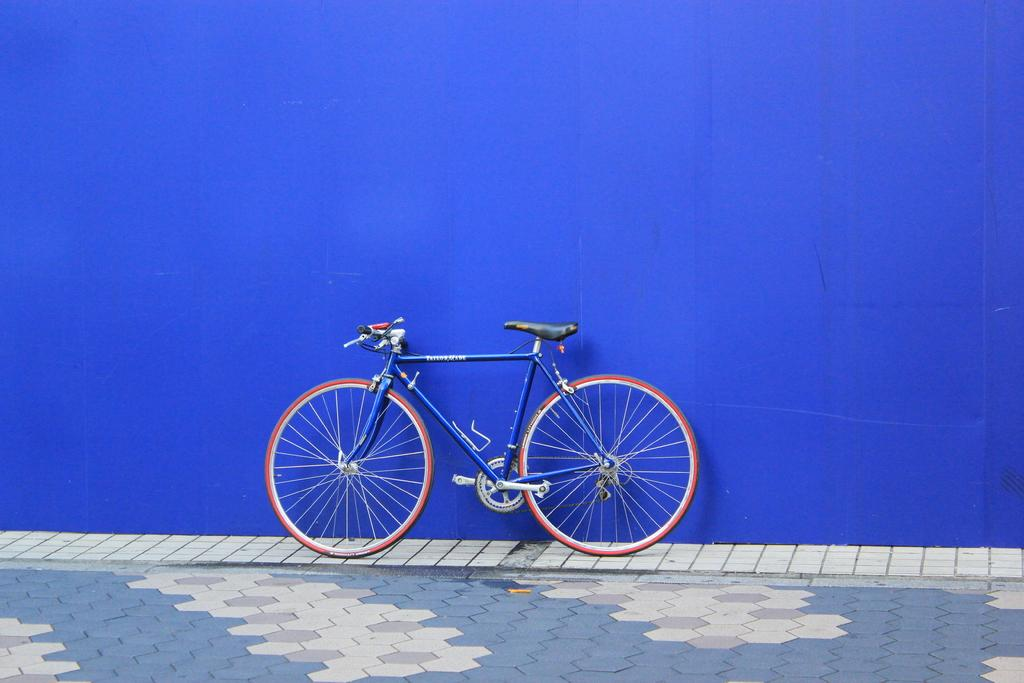What is the main object in the image? There is a bicycle in the image. What can be seen in the background of the image? There is a blue color wall in the background of the image. What type of flooring is visible at the bottom of the image? There are tiles at the bottom of the image. How many hands are holding the bicycle in the image? There are no hands visible in the image, and the bicycle is not being held by any hands. 